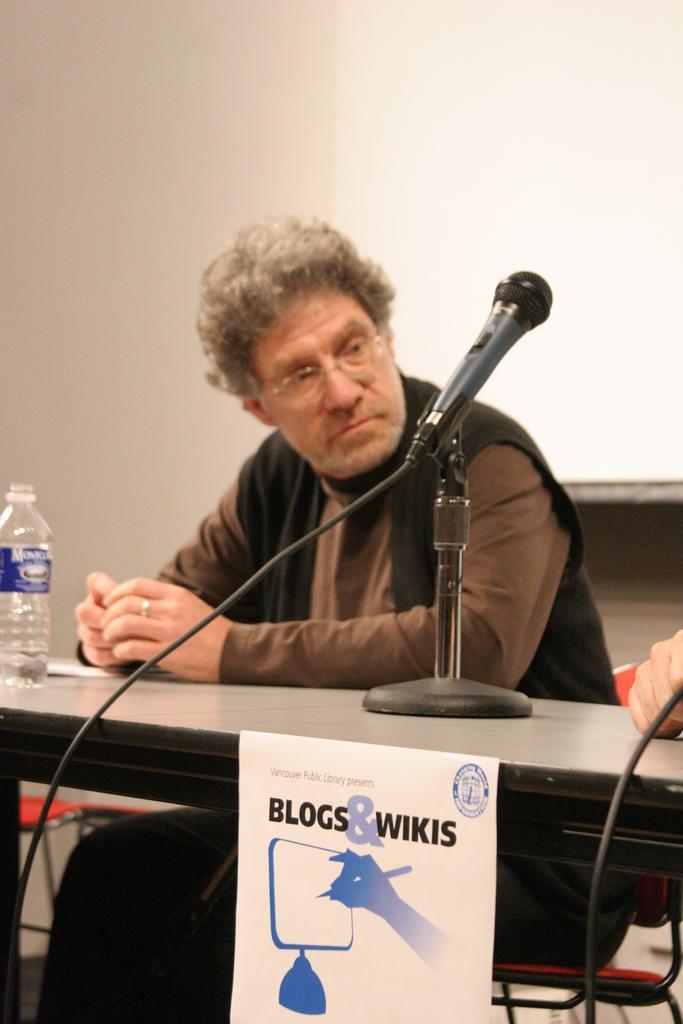Please provide a concise description of this image. In the image we can see there is a man who is sitting and on table there is a water bottle. 